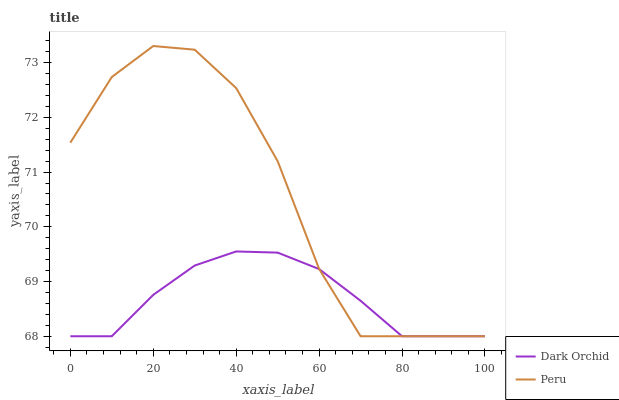Does Dark Orchid have the minimum area under the curve?
Answer yes or no. Yes. Does Peru have the maximum area under the curve?
Answer yes or no. Yes. Does Dark Orchid have the maximum area under the curve?
Answer yes or no. No. Is Dark Orchid the smoothest?
Answer yes or no. Yes. Is Peru the roughest?
Answer yes or no. Yes. Is Dark Orchid the roughest?
Answer yes or no. No. Does Peru have the lowest value?
Answer yes or no. Yes. Does Peru have the highest value?
Answer yes or no. Yes. Does Dark Orchid have the highest value?
Answer yes or no. No. Does Peru intersect Dark Orchid?
Answer yes or no. Yes. Is Peru less than Dark Orchid?
Answer yes or no. No. Is Peru greater than Dark Orchid?
Answer yes or no. No. 